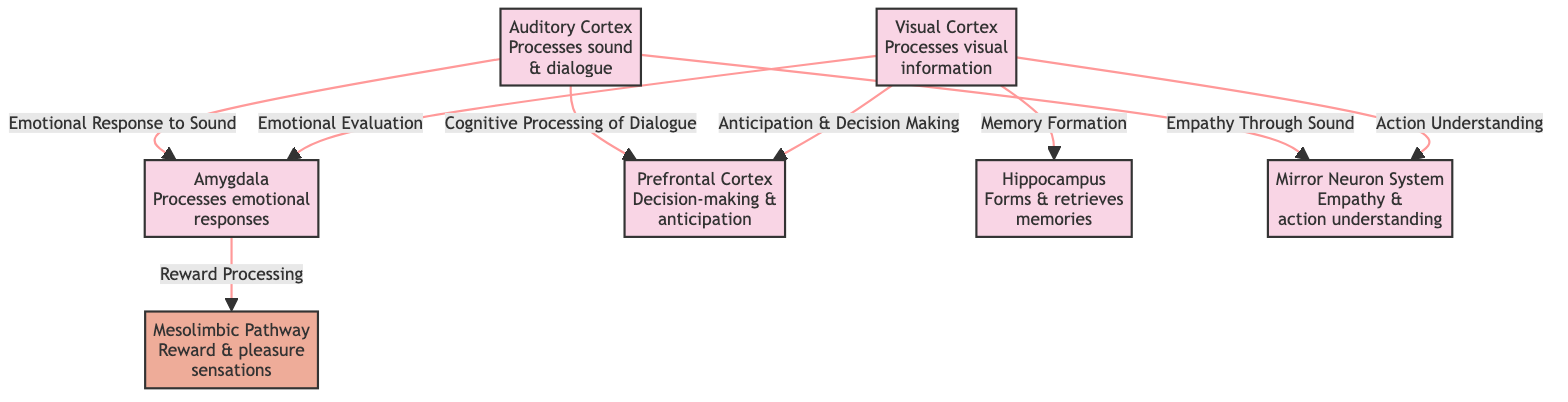what are the main brain areas involved in the neural response to artistic stimuli? The diagram highlights six brain areas: Visual Cortex, Amygdala, Prefrontal Cortex, Hippocampus, Auditory Cortex, and the Mirror Neuron System.
Answer: Visual Cortex, Amygdala, Prefrontal Cortex, Hippocampus, Auditory Cortex, Mirror Neuron System how many nodes are in the diagram? The diagram consists of a total of eight nodes: five brain areas (Visual Cortex, Amygdala, Prefrontal Cortex, Hippocampus, Auditory Cortex), the Mesolimbic Pathway, and the Mirror Neuron System.
Answer: 8 which brain area processes emotional responses? The diagram indicates that the Amygdala is responsible for processing emotional responses.
Answer: Amygdala how does the Visual Cortex influence the Prefrontal Cortex? The Visual Cortex influences the Prefrontal Cortex through anticipation and decision making, as indicated by the labeled arrow connecting them.
Answer: Anticipation & Decision Making what pathway is involved with reward processing? The Mesolimbic Pathway is illustrated as being responsible for reward processing, following the connection from the Amygdala.
Answer: Mesolimbic Pathway which brain area is linked to empathy through sound? The Mirror Neuron System is linked to empathy through sound, as can be seen from the connection from the Auditory Cortex.
Answer: Mirror Neuron System what two functions does the Hippocampus serve according to the diagram? According to the diagram, the Hippocampus is involved in forming and retrieving memories, as shown by the labels on the node.
Answer: Forms & retrieves memories what connections are made from the Auditory Cortex? The Auditory Cortex connects to the Amygdala for emotional response to sound and to the Prefrontal Cortex for cognitive processing of dialogue.
Answer: Emotional Response to Sound, Cognitive Processing of Dialogue 